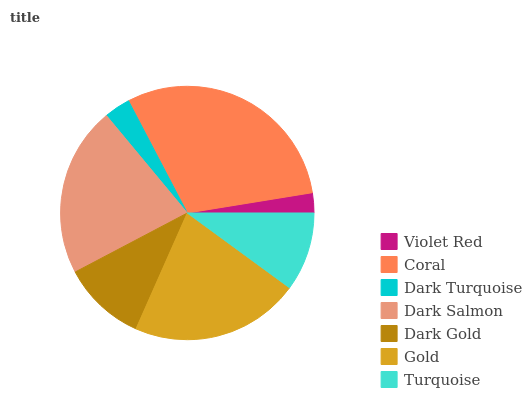Is Violet Red the minimum?
Answer yes or no. Yes. Is Coral the maximum?
Answer yes or no. Yes. Is Dark Turquoise the minimum?
Answer yes or no. No. Is Dark Turquoise the maximum?
Answer yes or no. No. Is Coral greater than Dark Turquoise?
Answer yes or no. Yes. Is Dark Turquoise less than Coral?
Answer yes or no. Yes. Is Dark Turquoise greater than Coral?
Answer yes or no. No. Is Coral less than Dark Turquoise?
Answer yes or no. No. Is Dark Gold the high median?
Answer yes or no. Yes. Is Dark Gold the low median?
Answer yes or no. Yes. Is Coral the high median?
Answer yes or no. No. Is Gold the low median?
Answer yes or no. No. 